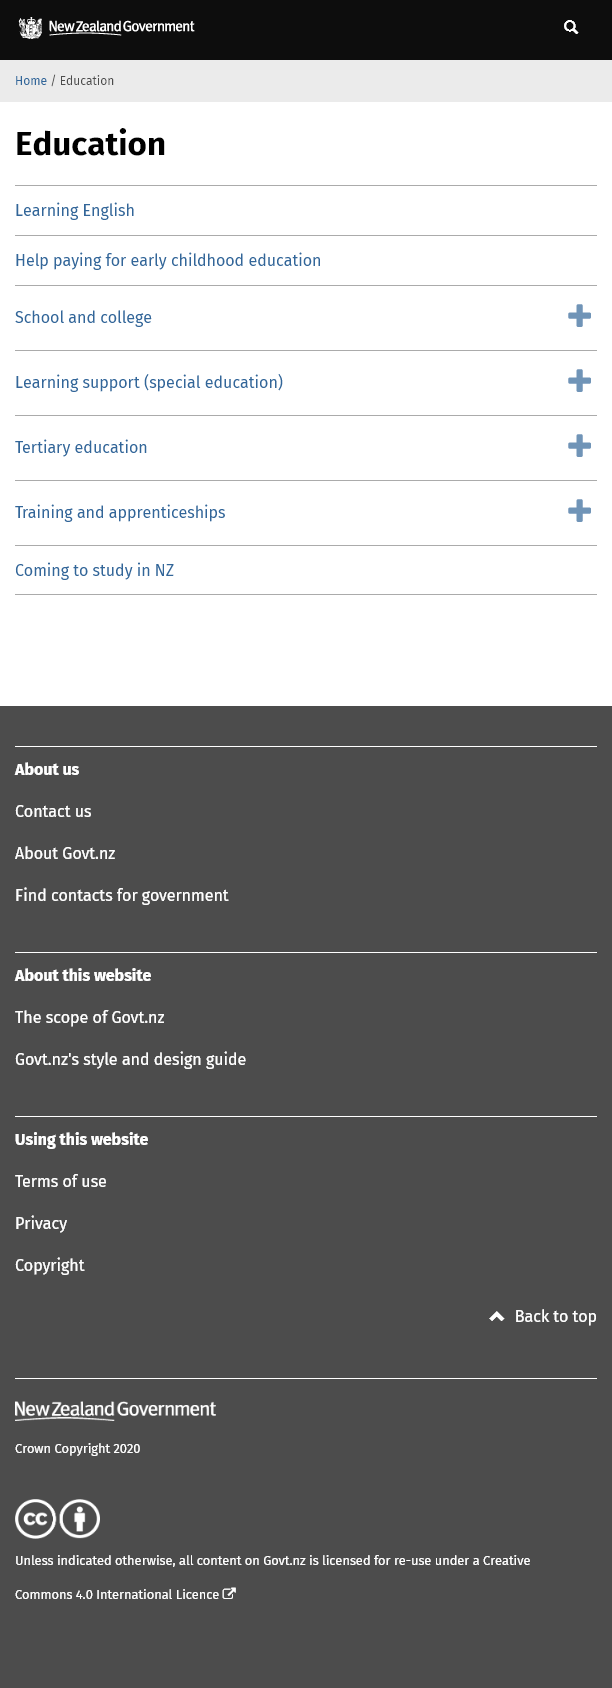Indicate a few pertinent items in this graphic. The country New Zealand is referenced in the sub-headings and is mentioned in the last option. There are seven sections that fall under the heading "Education". It is possible to receive financial assistance for early childhood education, including the cost of tuition and other related expenses. 